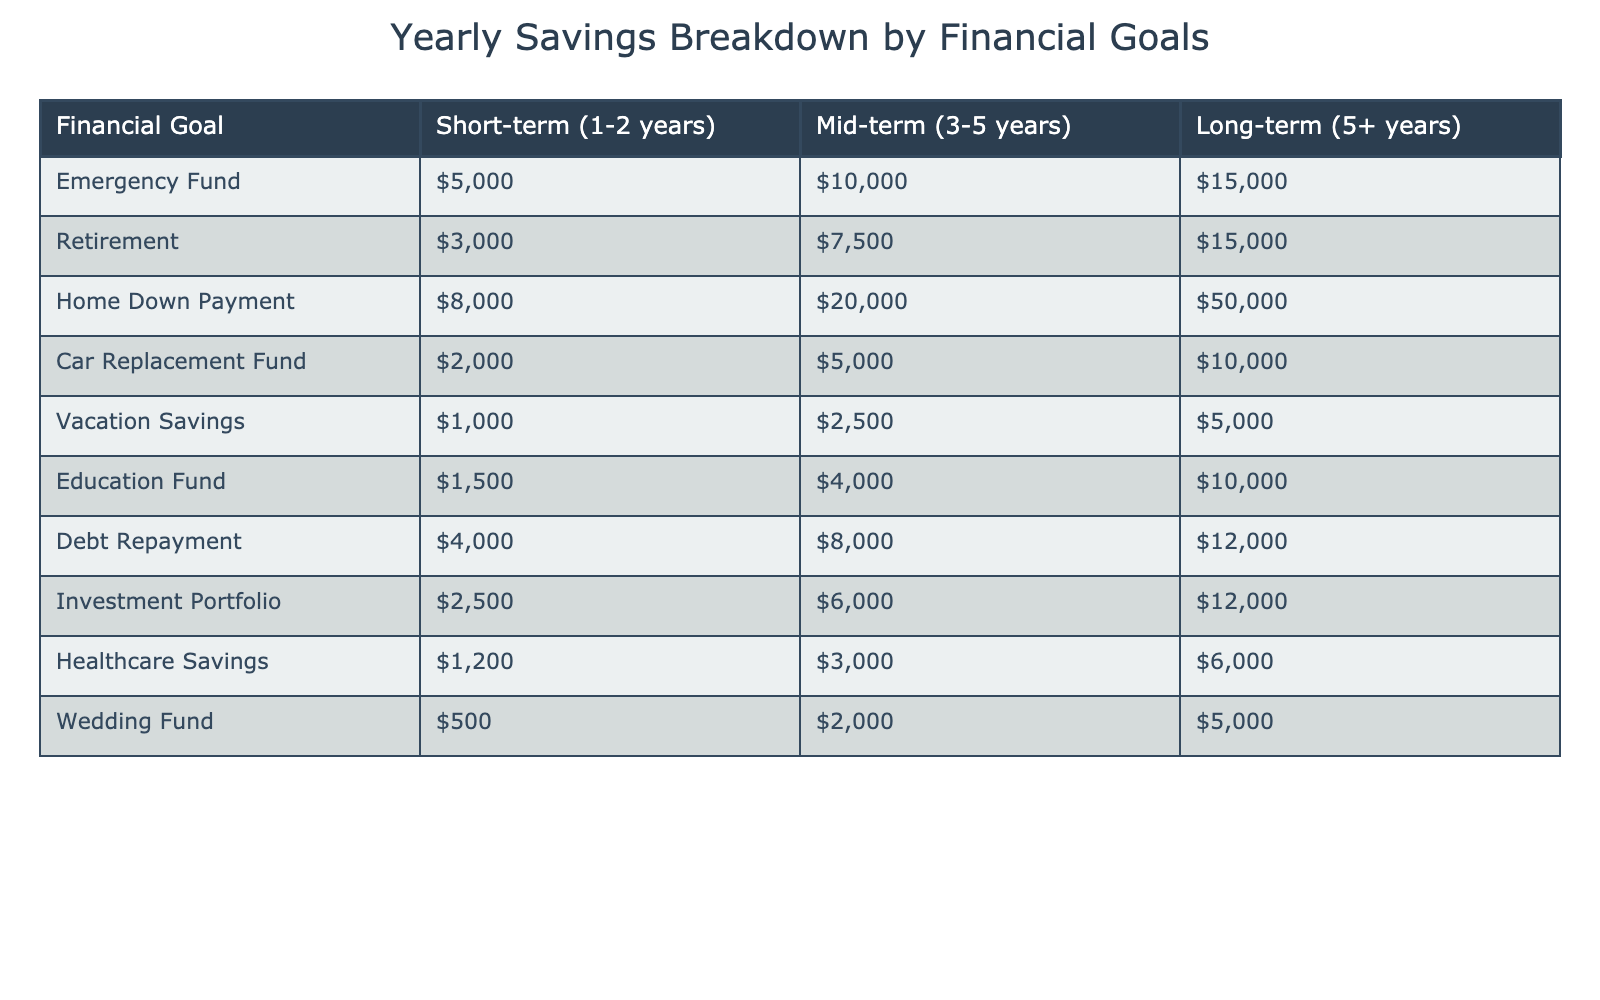What is the total amount set aside for the Home Down Payment in the long-term category? The long-term amount for the Home Down Payment is listed directly in the table as 50,000.
Answer: 50,000 How much more is allocated for the Emergency Fund compared to the Car Replacement Fund in the short-term? The Emergency Fund for short-term is 5,000, and the Car Replacement Fund is 2,000. The difference is 5,000 - 2,000 = 3,000.
Answer: 3,000 Which financial goal has the highest amount allocated in the mid-term category? Referring to the mid-term values in the table, the Home Down Payment has 20,000, which is the highest among all goals.
Answer: Home Down Payment What percentage of the total long-term savings is designated for retirement? The total long-term savings can be calculated by adding all long-term values: 15,000 (Emergency Fund) + 15,000 (Retirement) + 50,000 (Home Down Payment) + 10,000 (Car Replacement Fund) + 5,000 (Vacation Savings) + 10,000 (Education Fund) + 12,000 (Debt Repayment) + 12,000 (Investment Portfolio) + 6,000 (Healthcare Savings) + 5,000 (Wedding Fund) = 135,000. The allocation for retirement is 15,000. The percentage is (15,000 / 135,000) * 100 = 11.11%.
Answer: 11.11% Is the total savings for the Vacation Savings greater than that for the Debt Repayment in the mid-term? The mid-term savings for Vacation Savings is 2,500, while for Debt Repayment it is 8,000. Since 2,500 is less than 8,000, the answer is no.
Answer: No What is the combined total of the short-term savings for Car Replacement Fund and Vacation Savings? The short-term savings for the Car Replacement Fund is 2,000 and for Vacation Savings is 1,000. The combined total is 2,000 + 1,000 = 3,000.
Answer: 3,000 If I want to prioritize my education and healthcare savings in the mid-term, what is their combined total? The mid-term value for the Education Fund is 4,000 and for Healthcare Savings it is 3,000. The total combined is 4,000 + 3,000 = 7,000.
Answer: 7,000 How does the total amount for the Debt Repayment compare to that for the Investment Portfolio in the long-term category? The long-term amount for Debt Repayment is 12,000, while for Investment Portfolio it is also 12,000. Since both are equal, the comparison shows no difference.
Answer: They are equal What is the average amount of money allocated for short-term financial goals? The short-term financial goals total is 5,000 (Emergency Fund) + 3,000 (Retirement) + 8,000 (Home Down Payment) + 2,000 (Car Replacement Fund) + 1,000 (Vacation Savings) + 1,500 (Education Fund) + 4,000 (Debt Repayment) + 2,500 (Investment Portfolio) + 1,200 (Healthcare Savings) + 500 (Wedding Fund) = 29,700. With 10 goals, the average is 29,700 / 10 = 2,970.
Answer: 2,970 Which financial goal has the least amount allocated overall? By reviewing the total of each financial goal across all time frames, the Wedding Fund has the least total with 500 + 2,000 + 5,000 = 7,500.
Answer: Wedding Fund 